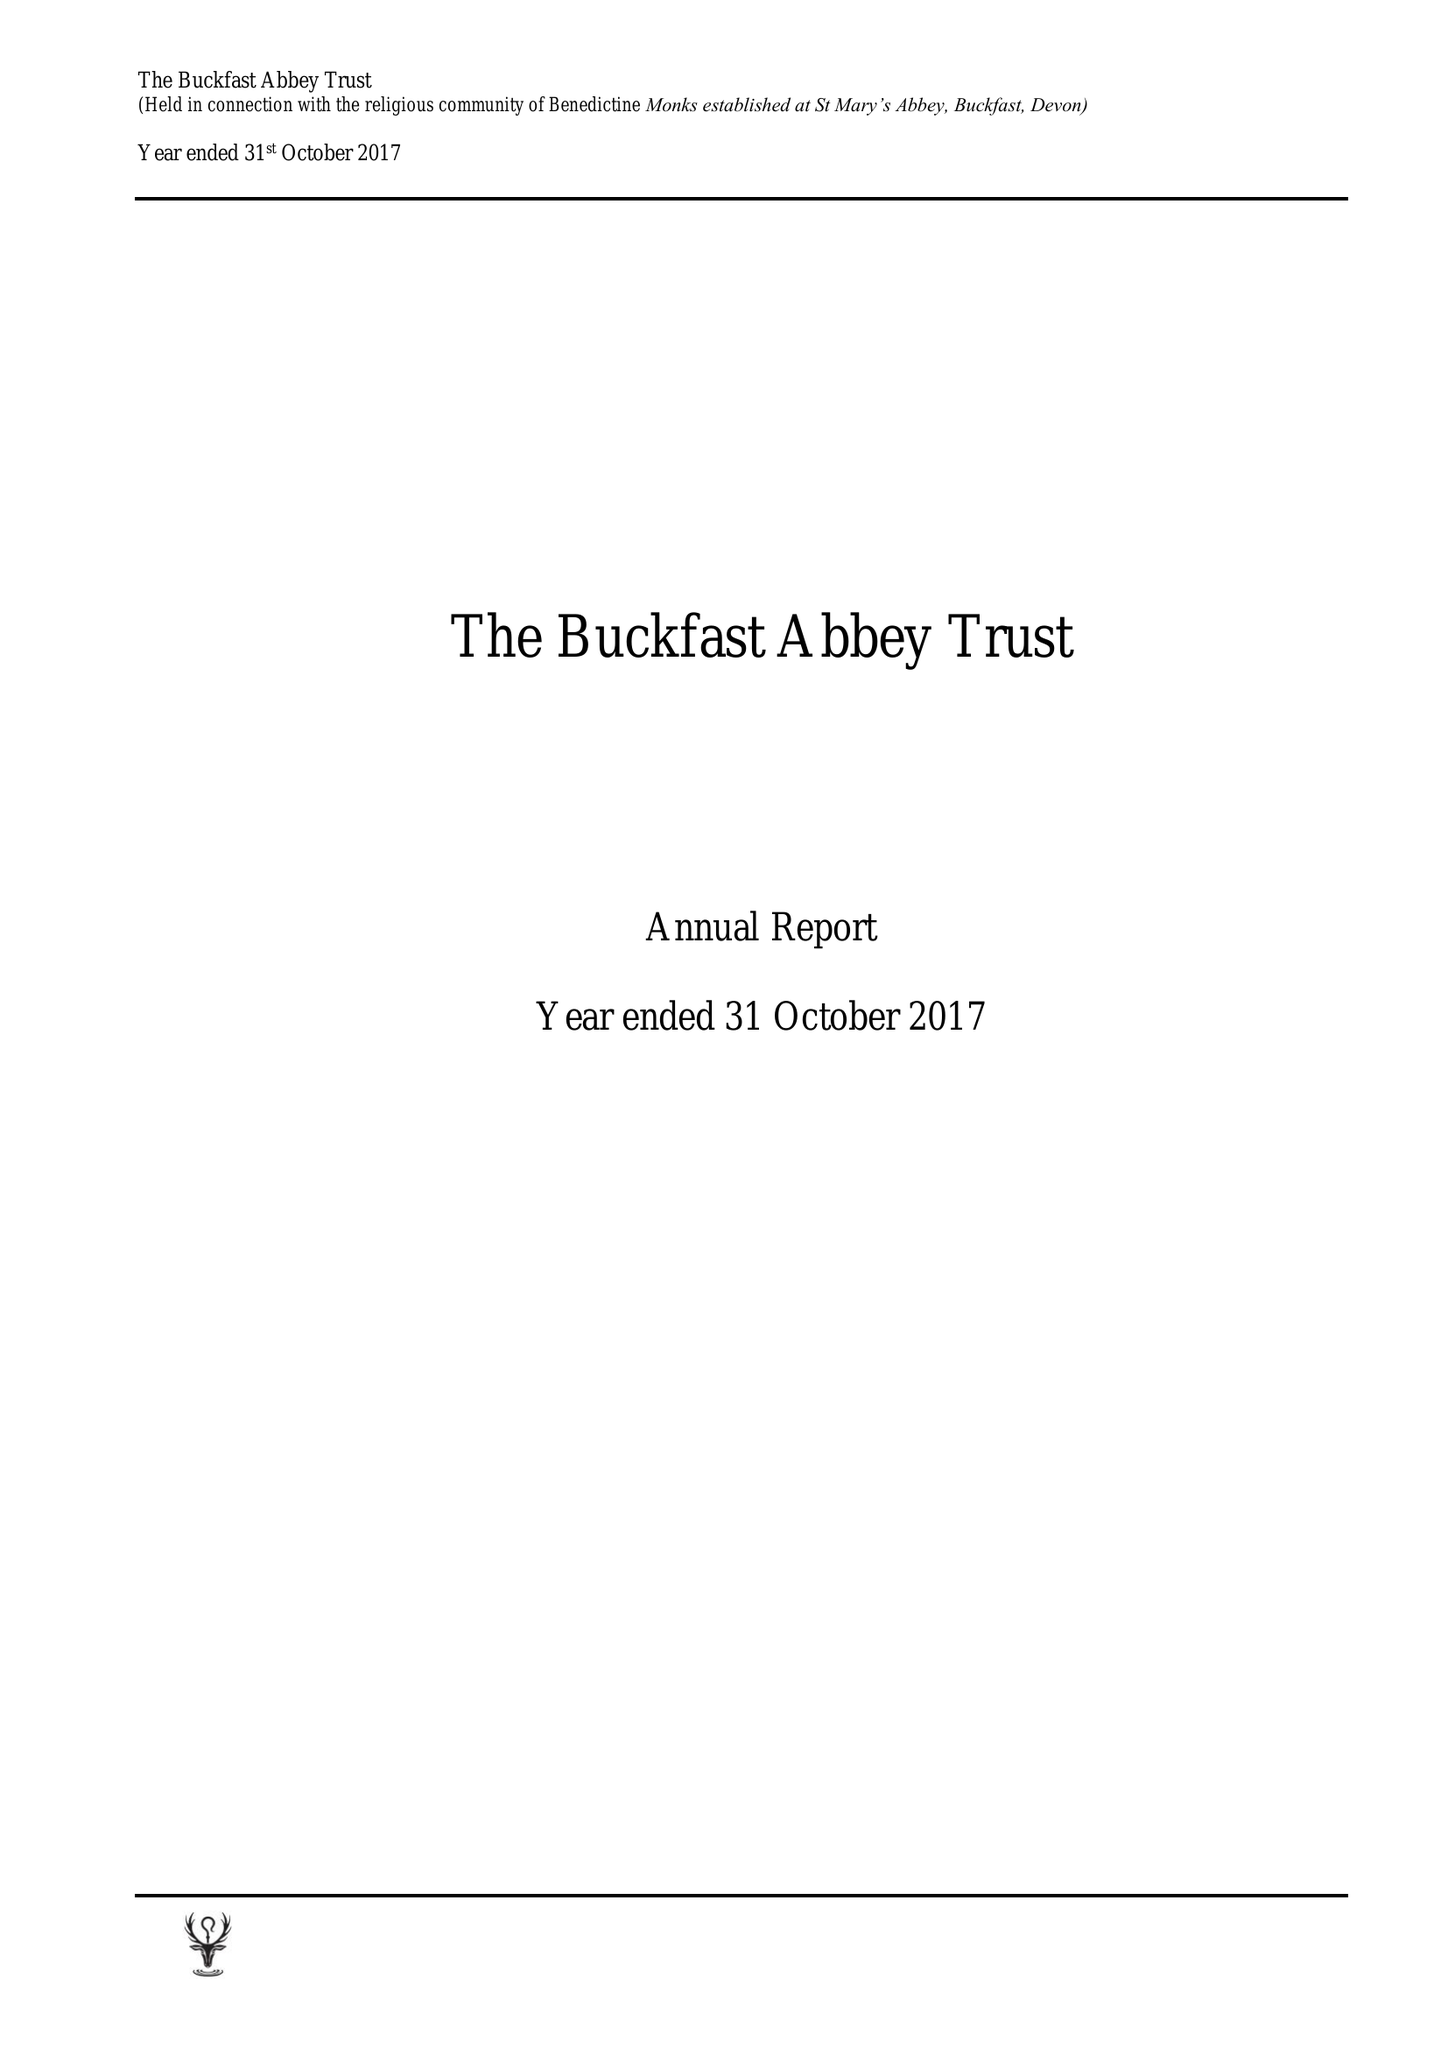What is the value for the report_date?
Answer the question using a single word or phrase. 2017-10-31 